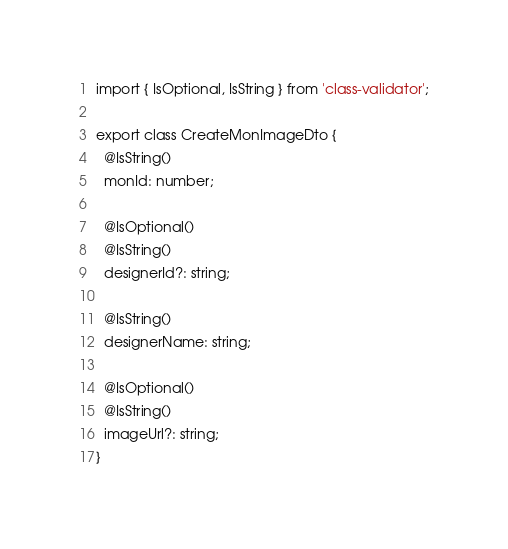Convert code to text. <code><loc_0><loc_0><loc_500><loc_500><_TypeScript_>import { IsOptional, IsString } from 'class-validator';

export class CreateMonImageDto {
  @IsString()
  monId: number;

  @IsOptional()
  @IsString()
  designerId?: string;

  @IsString()
  designerName: string;

  @IsOptional()
  @IsString()
  imageUrl?: string;
}
</code> 